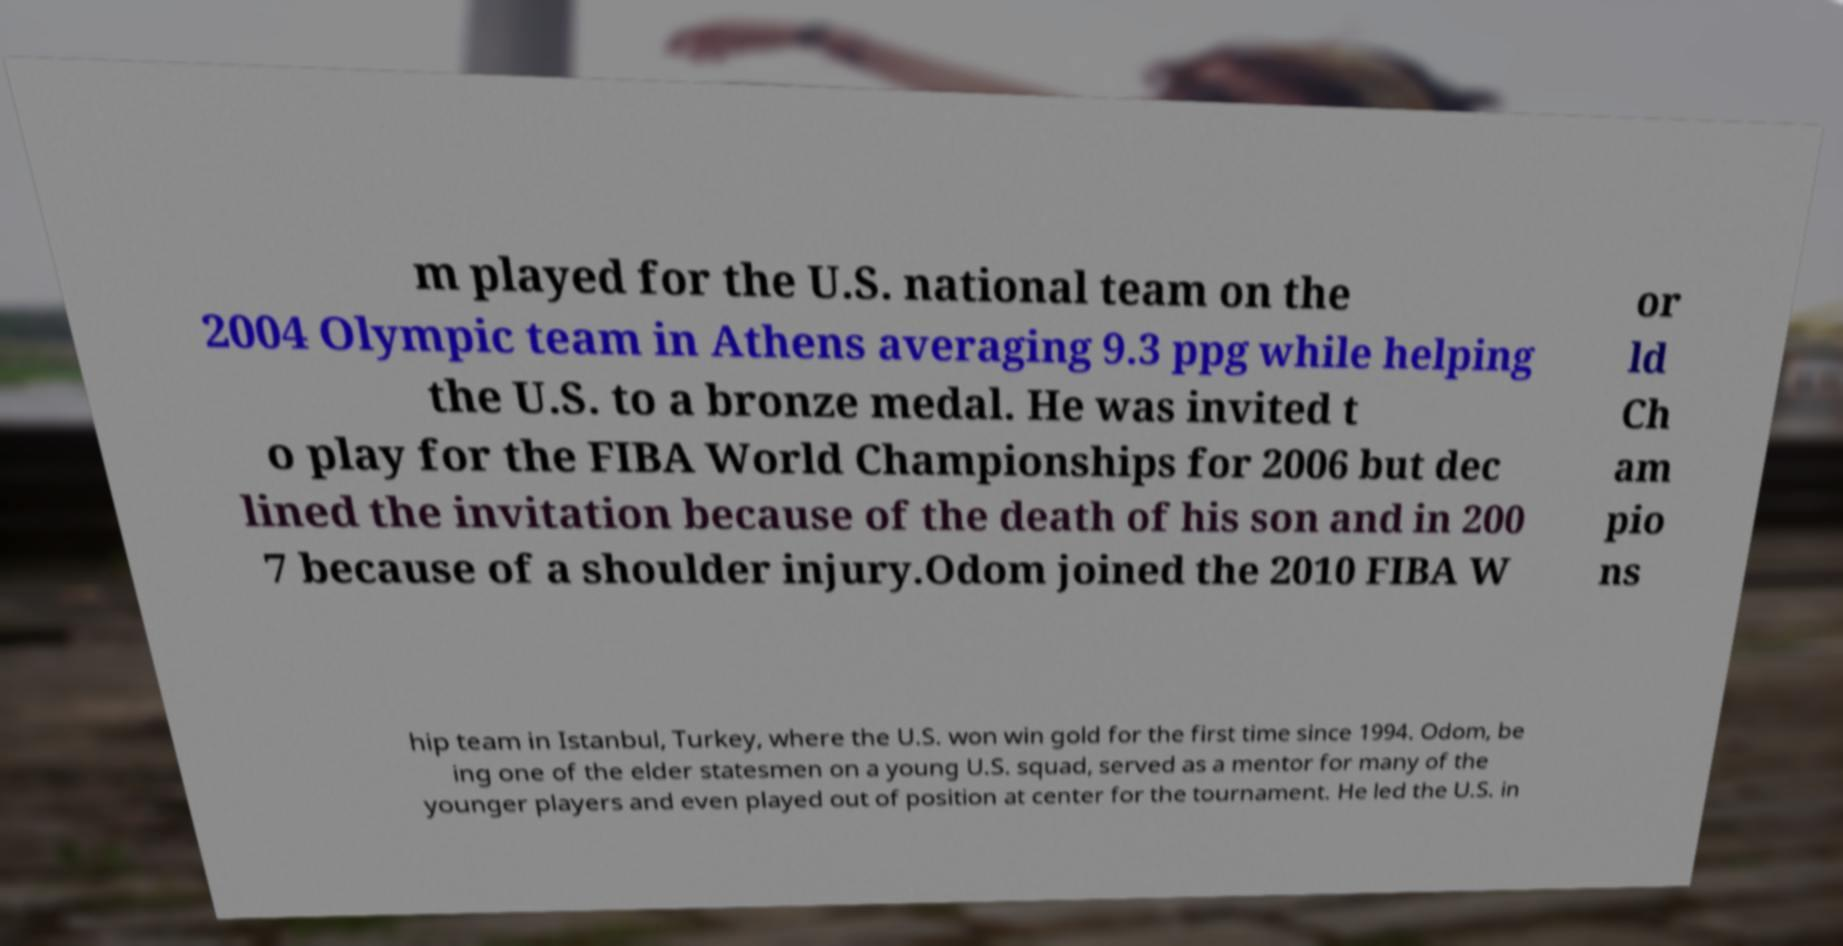I need the written content from this picture converted into text. Can you do that? m played for the U.S. national team on the 2004 Olympic team in Athens averaging 9.3 ppg while helping the U.S. to a bronze medal. He was invited t o play for the FIBA World Championships for 2006 but dec lined the invitation because of the death of his son and in 200 7 because of a shoulder injury.Odom joined the 2010 FIBA W or ld Ch am pio ns hip team in Istanbul, Turkey, where the U.S. won win gold for the first time since 1994. Odom, be ing one of the elder statesmen on a young U.S. squad, served as a mentor for many of the younger players and even played out of position at center for the tournament. He led the U.S. in 